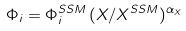Convert formula to latex. <formula><loc_0><loc_0><loc_500><loc_500>\Phi _ { i } = \Phi _ { i } ^ { S S M } \, ( X / X ^ { S S M } ) ^ { \alpha _ { X } }</formula> 